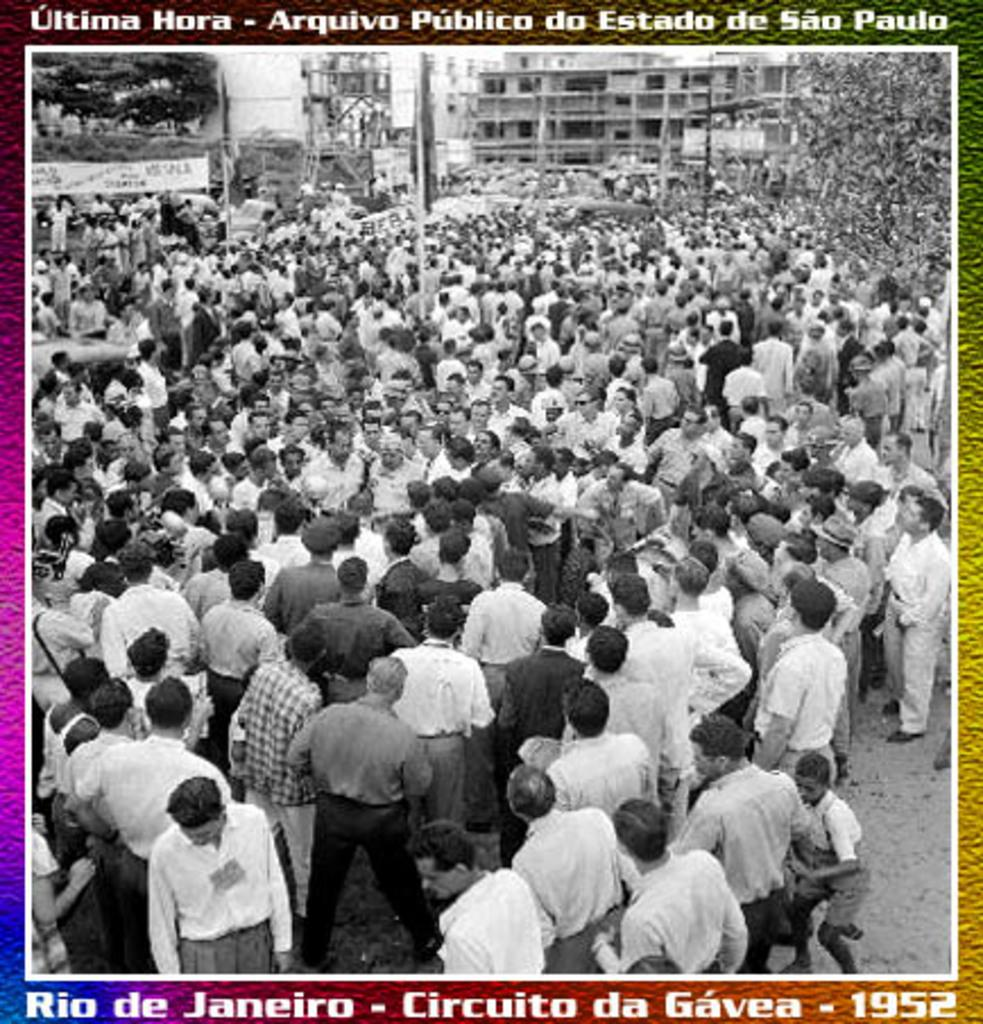What is happening in the image? There are people standing in the image. What color scheme is used in the image? The image is black and white in color. Are there any additional features visible in the image? Yes, there are watermarks in the image. How many rabbits can be seen playing with a quill in the image? There are no rabbits or quills present in the image. Is there a farm visible in the background of the image? There is no farm visible in the image; it only features people standing and watermarks. 